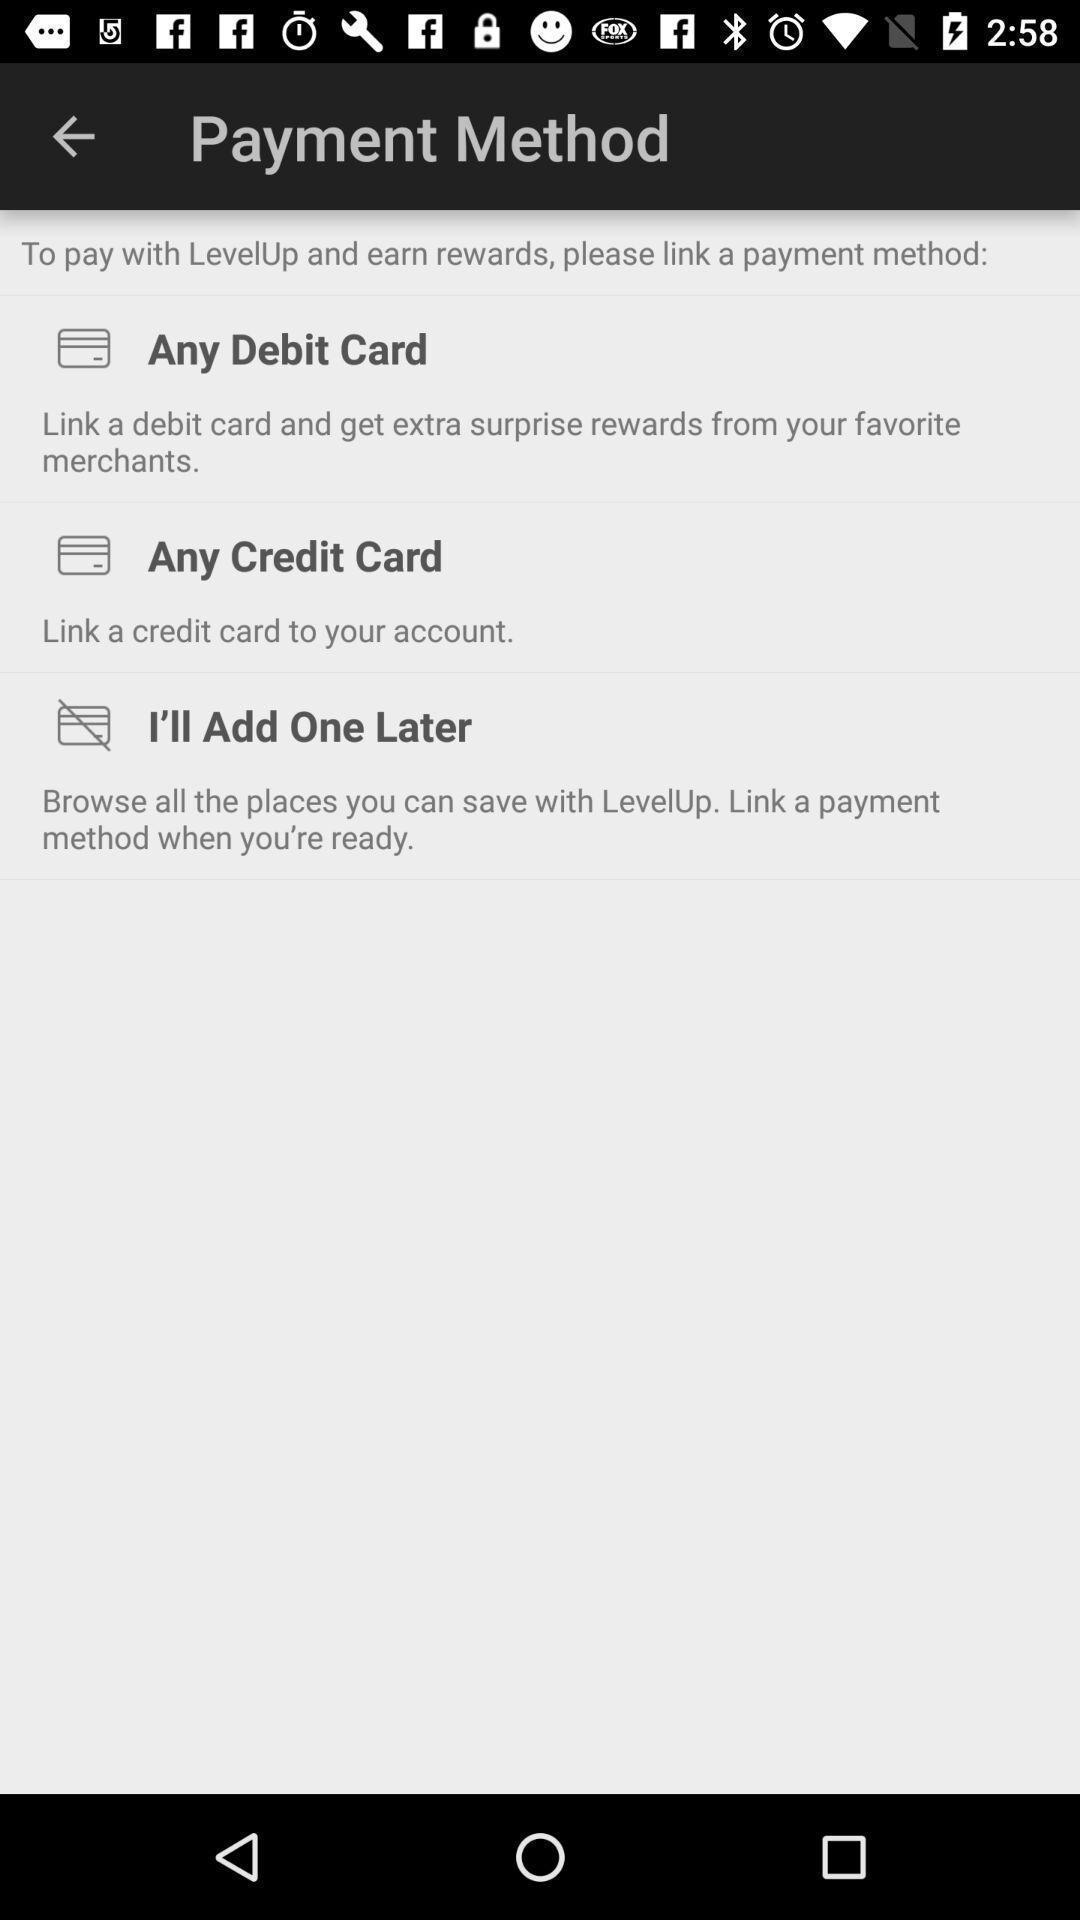Describe the visual elements of this screenshot. Page shows to choose your payment method in payment app. 